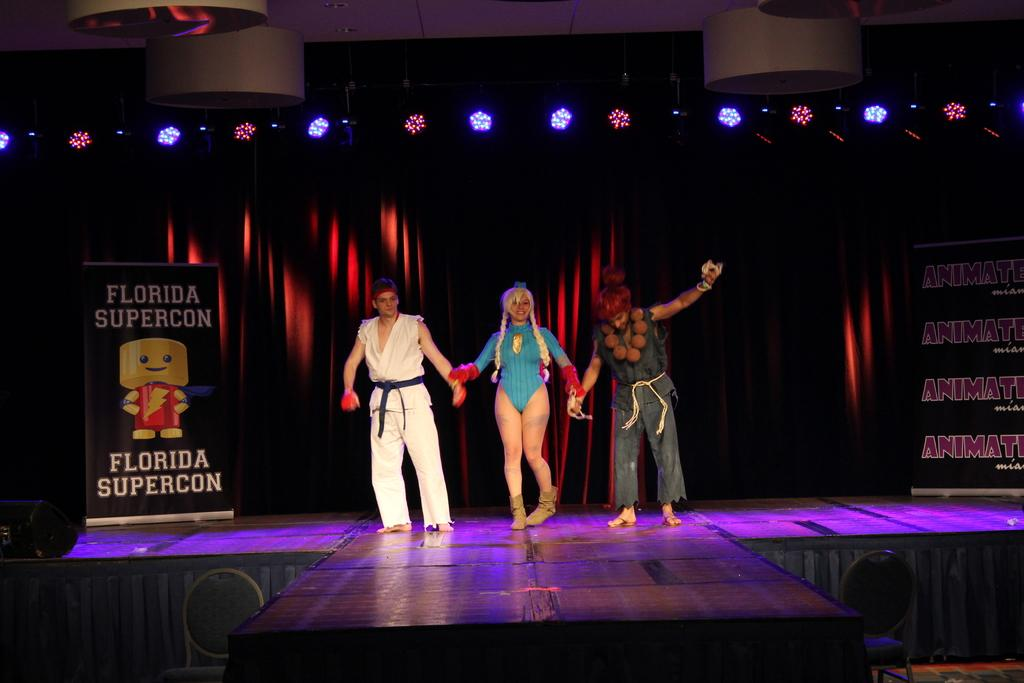Provide a one-sentence caption for the provided image. Three people in anime costumes are walking down a stage by a sign that says Florida Supercon. 